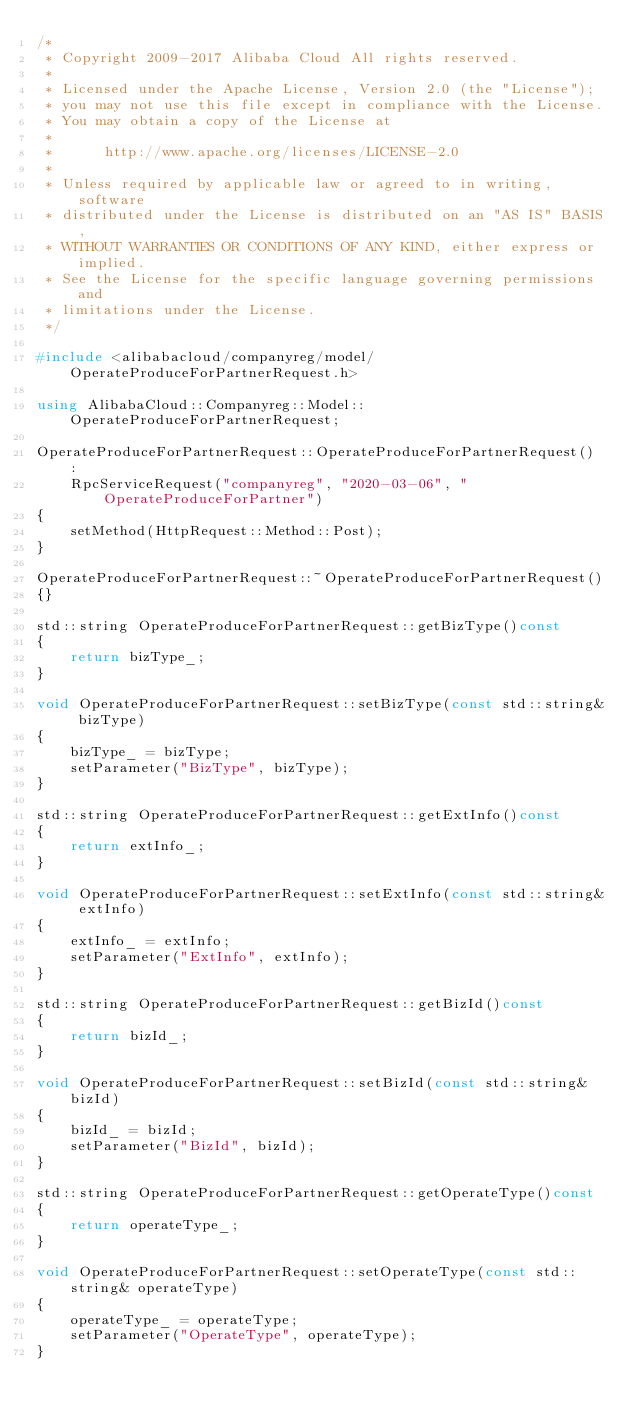Convert code to text. <code><loc_0><loc_0><loc_500><loc_500><_C++_>/*
 * Copyright 2009-2017 Alibaba Cloud All rights reserved.
 * 
 * Licensed under the Apache License, Version 2.0 (the "License");
 * you may not use this file except in compliance with the License.
 * You may obtain a copy of the License at
 * 
 *      http://www.apache.org/licenses/LICENSE-2.0
 * 
 * Unless required by applicable law or agreed to in writing, software
 * distributed under the License is distributed on an "AS IS" BASIS,
 * WITHOUT WARRANTIES OR CONDITIONS OF ANY KIND, either express or implied.
 * See the License for the specific language governing permissions and
 * limitations under the License.
 */

#include <alibabacloud/companyreg/model/OperateProduceForPartnerRequest.h>

using AlibabaCloud::Companyreg::Model::OperateProduceForPartnerRequest;

OperateProduceForPartnerRequest::OperateProduceForPartnerRequest() :
	RpcServiceRequest("companyreg", "2020-03-06", "OperateProduceForPartner")
{
	setMethod(HttpRequest::Method::Post);
}

OperateProduceForPartnerRequest::~OperateProduceForPartnerRequest()
{}

std::string OperateProduceForPartnerRequest::getBizType()const
{
	return bizType_;
}

void OperateProduceForPartnerRequest::setBizType(const std::string& bizType)
{
	bizType_ = bizType;
	setParameter("BizType", bizType);
}

std::string OperateProduceForPartnerRequest::getExtInfo()const
{
	return extInfo_;
}

void OperateProduceForPartnerRequest::setExtInfo(const std::string& extInfo)
{
	extInfo_ = extInfo;
	setParameter("ExtInfo", extInfo);
}

std::string OperateProduceForPartnerRequest::getBizId()const
{
	return bizId_;
}

void OperateProduceForPartnerRequest::setBizId(const std::string& bizId)
{
	bizId_ = bizId;
	setParameter("BizId", bizId);
}

std::string OperateProduceForPartnerRequest::getOperateType()const
{
	return operateType_;
}

void OperateProduceForPartnerRequest::setOperateType(const std::string& operateType)
{
	operateType_ = operateType;
	setParameter("OperateType", operateType);
}

</code> 